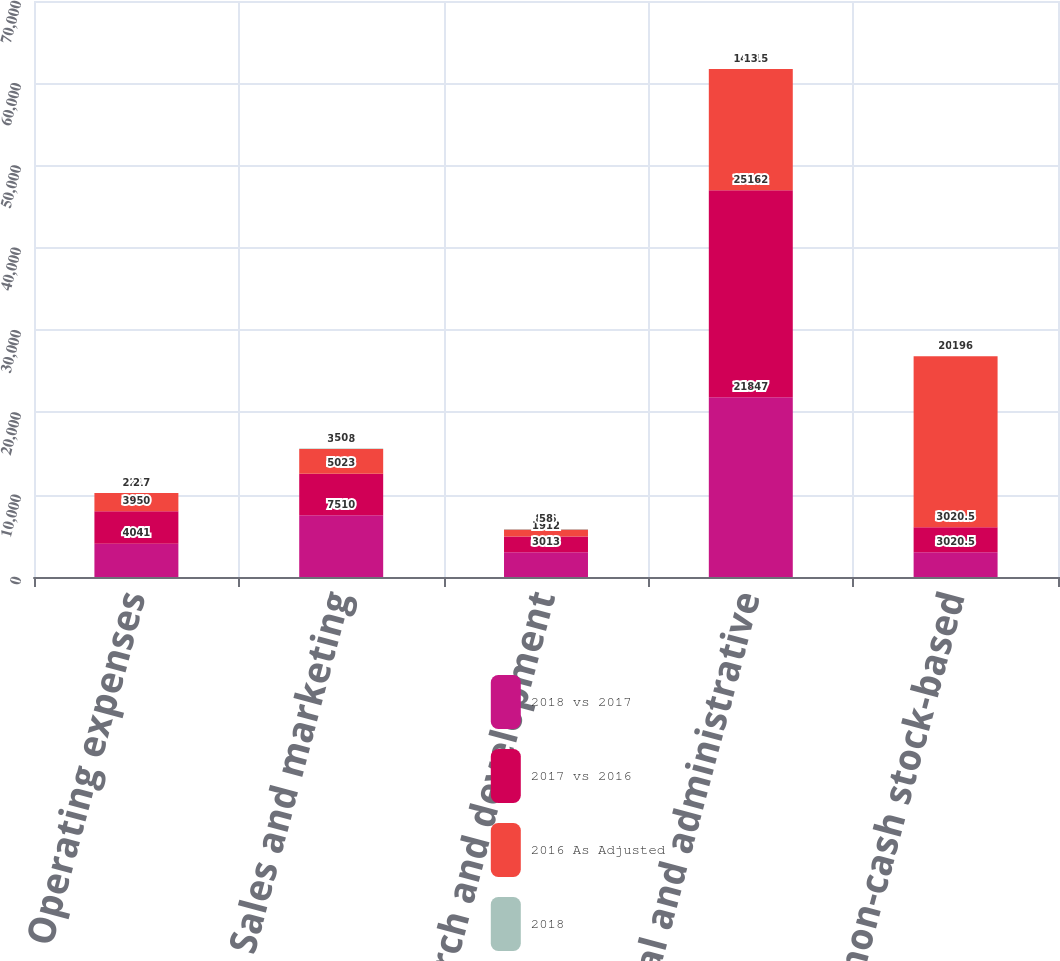Convert chart to OTSL. <chart><loc_0><loc_0><loc_500><loc_500><stacked_bar_chart><ecel><fcel>Operating expenses<fcel>Sales and marketing<fcel>Research and development<fcel>General and administrative<fcel>Total non-cash stock-based<nl><fcel>2018 vs 2017<fcel>4041<fcel>7510<fcel>3013<fcel>21847<fcel>3020.5<nl><fcel>2017 vs 2016<fcel>3950<fcel>5023<fcel>1912<fcel>25162<fcel>3020.5<nl><fcel>2016 As Adjusted<fcel>2217<fcel>3028<fcel>836<fcel>14715<fcel>20796<nl><fcel>2018<fcel>2<fcel>50<fcel>58<fcel>13<fcel>1<nl></chart> 